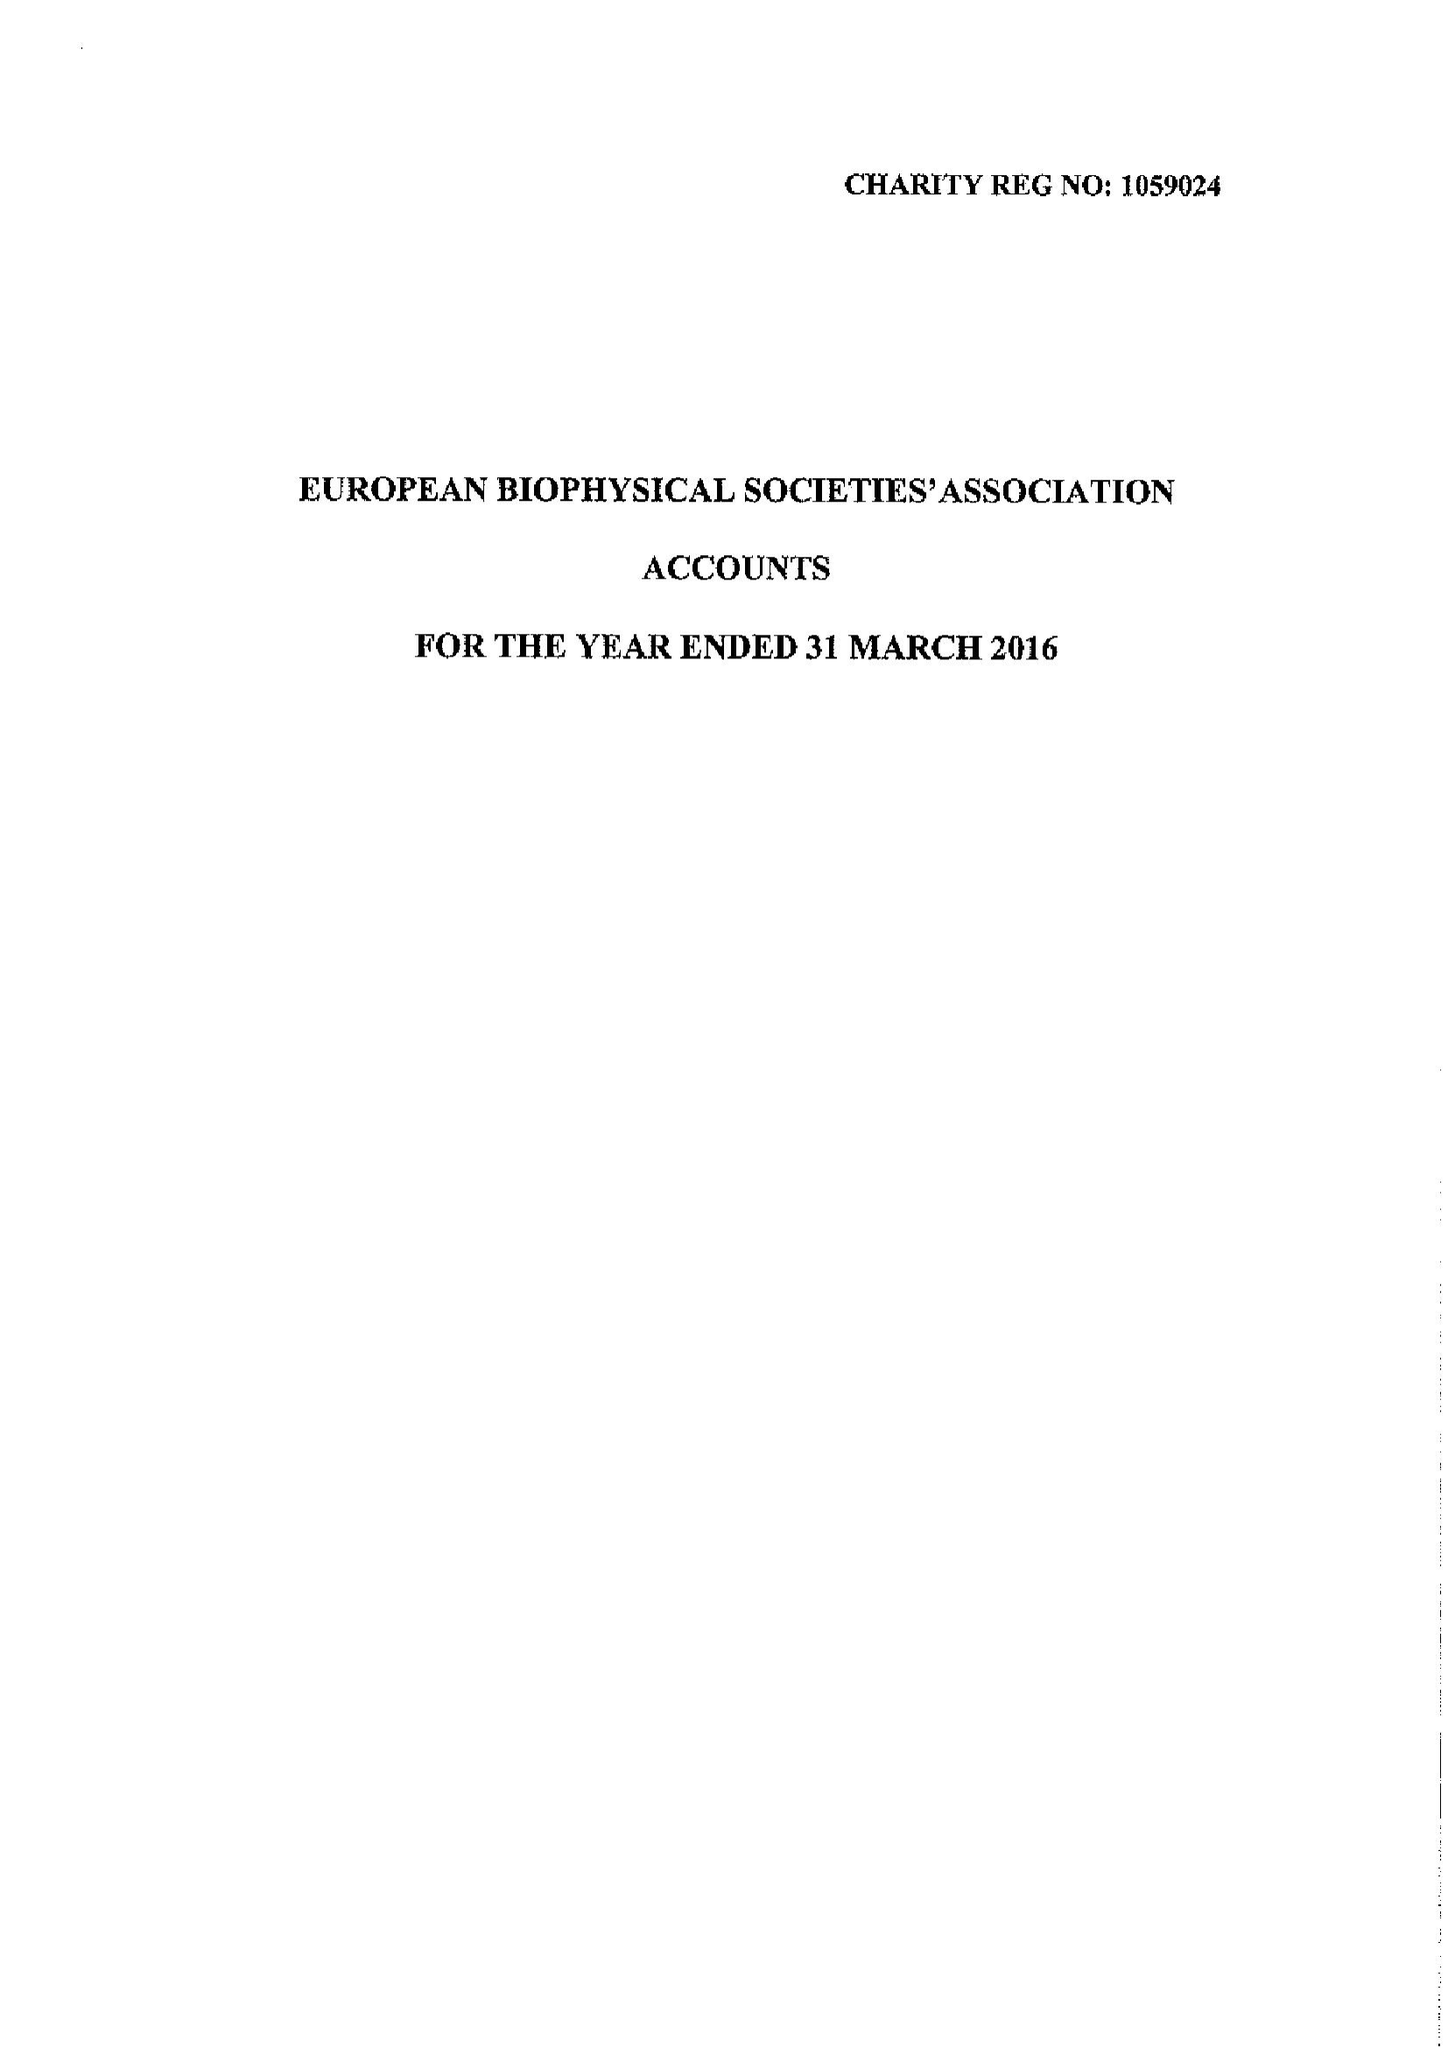What is the value for the charity_number?
Answer the question using a single word or phrase. 1059024 